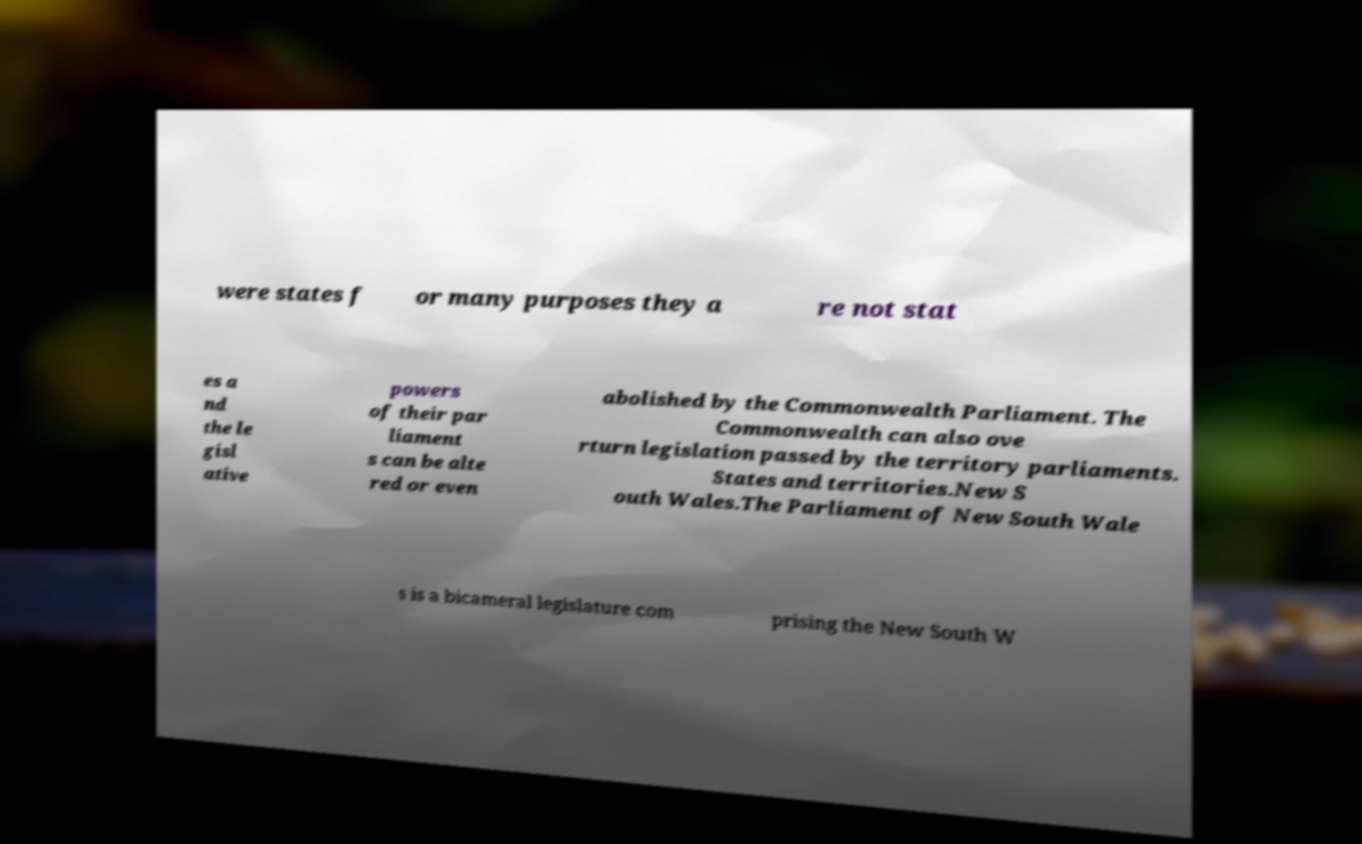For documentation purposes, I need the text within this image transcribed. Could you provide that? were states f or many purposes they a re not stat es a nd the le gisl ative powers of their par liament s can be alte red or even abolished by the Commonwealth Parliament. The Commonwealth can also ove rturn legislation passed by the territory parliaments. States and territories.New S outh Wales.The Parliament of New South Wale s is a bicameral legislature com prising the New South W 